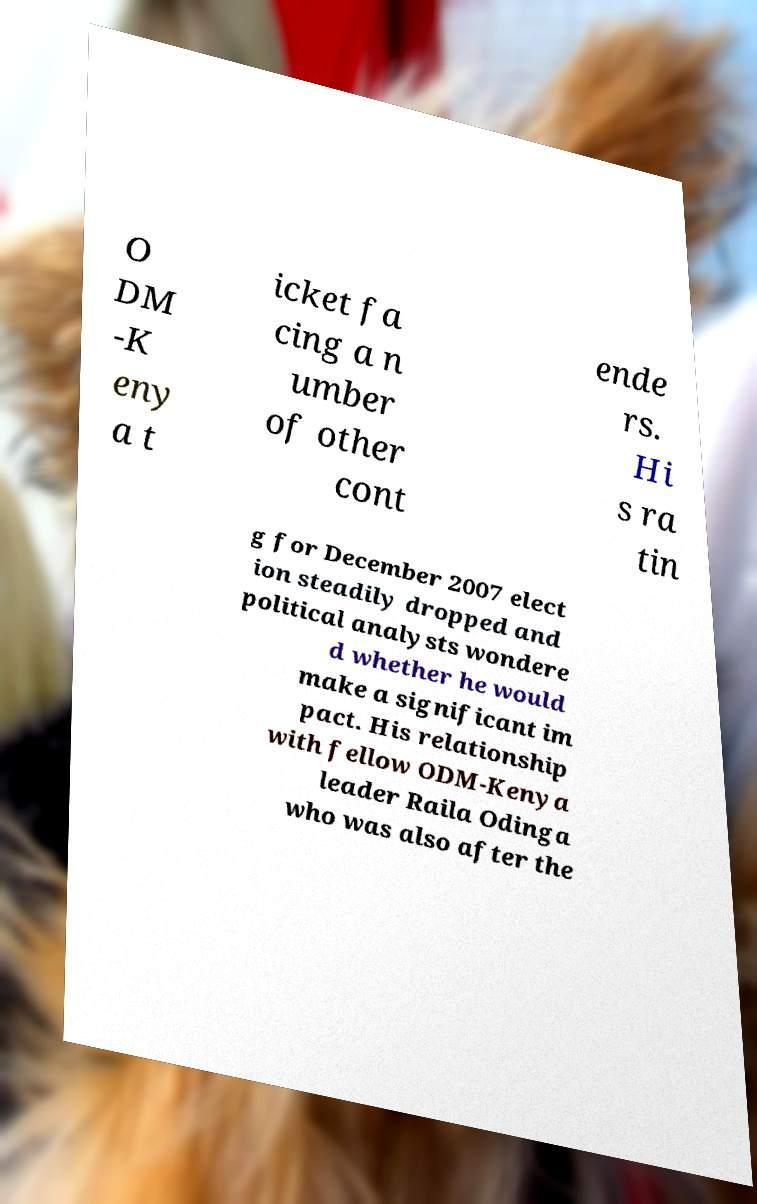Can you read and provide the text displayed in the image?This photo seems to have some interesting text. Can you extract and type it out for me? O DM -K eny a t icket fa cing a n umber of other cont ende rs. Hi s ra tin g for December 2007 elect ion steadily dropped and political analysts wondere d whether he would make a significant im pact. His relationship with fellow ODM-Kenya leader Raila Odinga who was also after the 